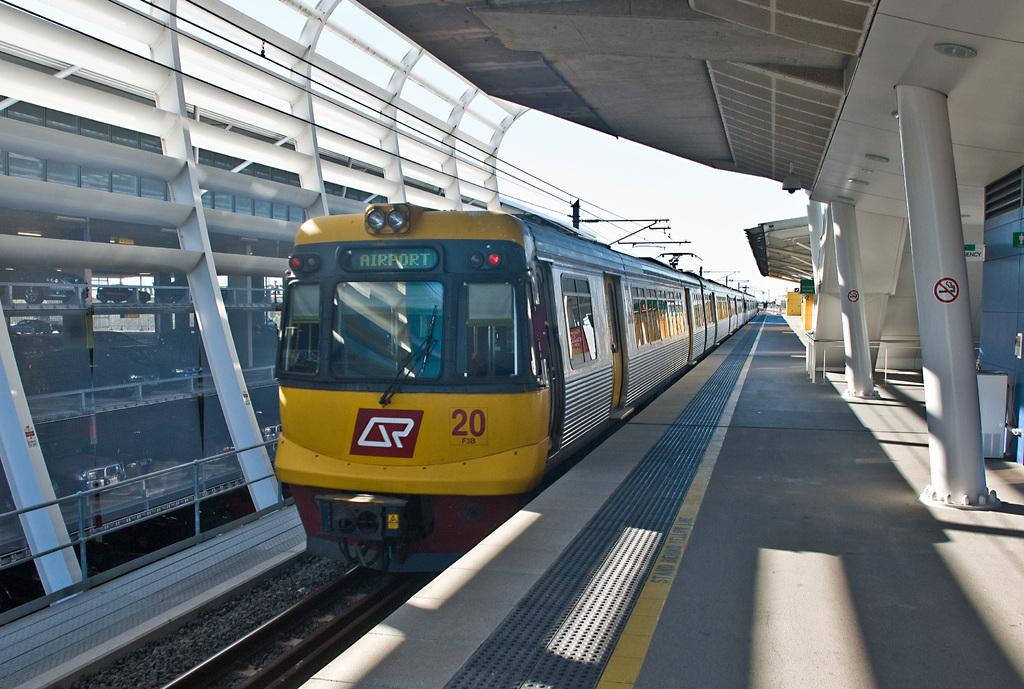What is the main subject of the image? The main subject of the image is a train. Where is the train located in the image? The train is on a railway track. What else can be seen in the image besides the train? There is a platform visible in the image, and cars are parked and visible through a glass (possibly a window). How would you describe the weather in the image? The sky is cloudy in the image, suggesting a potentially overcast or cloudy day. What type of egg is being used to power the train in the image? There is no egg present in the image, and the train is not powered by an egg. Can you see a chain attached to the train in the image? There is no chain attached to the train visible in the image. 